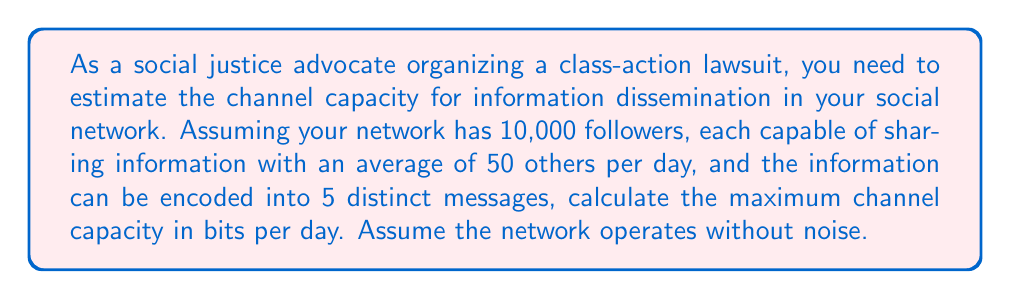Teach me how to tackle this problem. To solve this problem, we'll use Shannon's Channel Capacity formula and concepts from information theory:

1) Channel Capacity formula: $C = B \log_2(1 + S/N)$

   Where:
   $C$ = Channel capacity in bits per second
   $B$ = Bandwidth (in this case, number of messages per day)
   $S/N$ = Signal-to-noise ratio (in this case, infinite as we assume no noise)

2) First, calculate the total number of message transmissions per day:
   $\text{Total transmissions} = 10,000 \text{ followers} \times 50 \text{ transmissions/follower} = 500,000$

3) The bandwidth $B$ is 500,000 messages per day.

4) With 5 distinct messages, we have $\log_2(5)$ bits of information per message.

5) As we assume no noise, $S/N$ approaches infinity. $\lim_{S/N \to \infty} \log_2(1 + S/N) = \log_2(5)$

6) Substituting into the formula:

   $C = 500,000 \times \log_2(5)$ bits per day

7) Calculate:
   $\log_2(5) \approx 2.32193$
   $C = 500,000 \times 2.32193 = 1,160,965$ bits per day

Therefore, the maximum channel capacity is approximately 1,160,965 bits per day.
Answer: 1,160,965 bits per day 